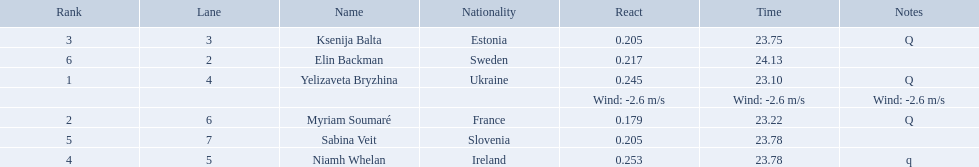What place did elin backman finish the race in? 6. How long did it take him to finish? 24.13. 